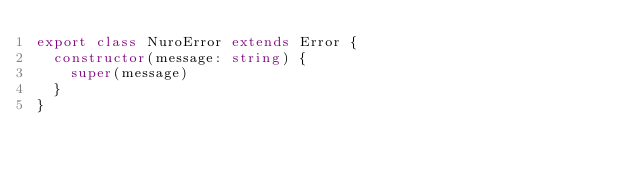<code> <loc_0><loc_0><loc_500><loc_500><_TypeScript_>export class NuroError extends Error {
  constructor(message: string) {
    super(message)
  }
}
</code> 